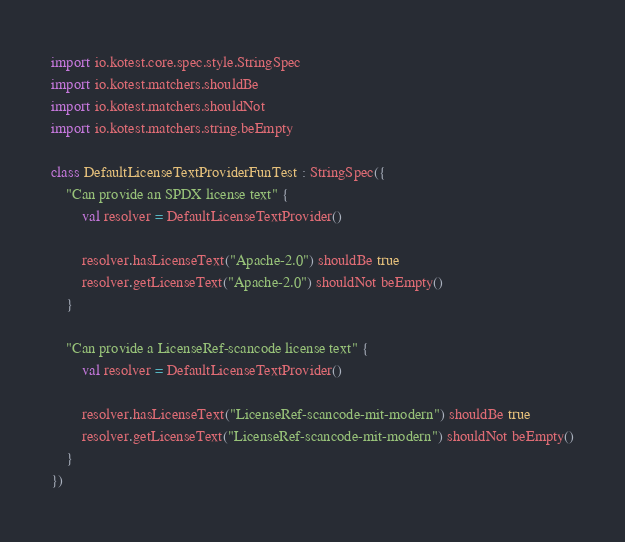Convert code to text. <code><loc_0><loc_0><loc_500><loc_500><_Kotlin_>import io.kotest.core.spec.style.StringSpec
import io.kotest.matchers.shouldBe
import io.kotest.matchers.shouldNot
import io.kotest.matchers.string.beEmpty

class DefaultLicenseTextProviderFunTest : StringSpec({
    "Can provide an SPDX license text" {
        val resolver = DefaultLicenseTextProvider()

        resolver.hasLicenseText("Apache-2.0") shouldBe true
        resolver.getLicenseText("Apache-2.0") shouldNot beEmpty()
    }

    "Can provide a LicenseRef-scancode license text" {
        val resolver = DefaultLicenseTextProvider()

        resolver.hasLicenseText("LicenseRef-scancode-mit-modern") shouldBe true
        resolver.getLicenseText("LicenseRef-scancode-mit-modern") shouldNot beEmpty()
    }
})
</code> 